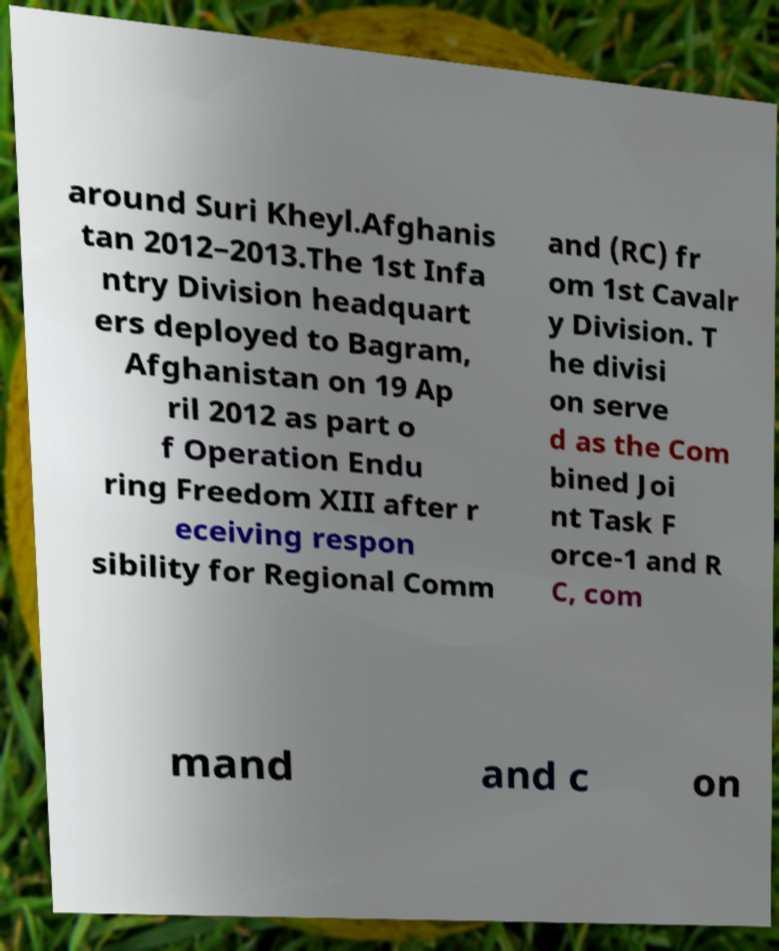For documentation purposes, I need the text within this image transcribed. Could you provide that? around Suri Kheyl.Afghanis tan 2012–2013.The 1st Infa ntry Division headquart ers deployed to Bagram, Afghanistan on 19 Ap ril 2012 as part o f Operation Endu ring Freedom XIII after r eceiving respon sibility for Regional Comm and (RC) fr om 1st Cavalr y Division. T he divisi on serve d as the Com bined Joi nt Task F orce-1 and R C, com mand and c on 